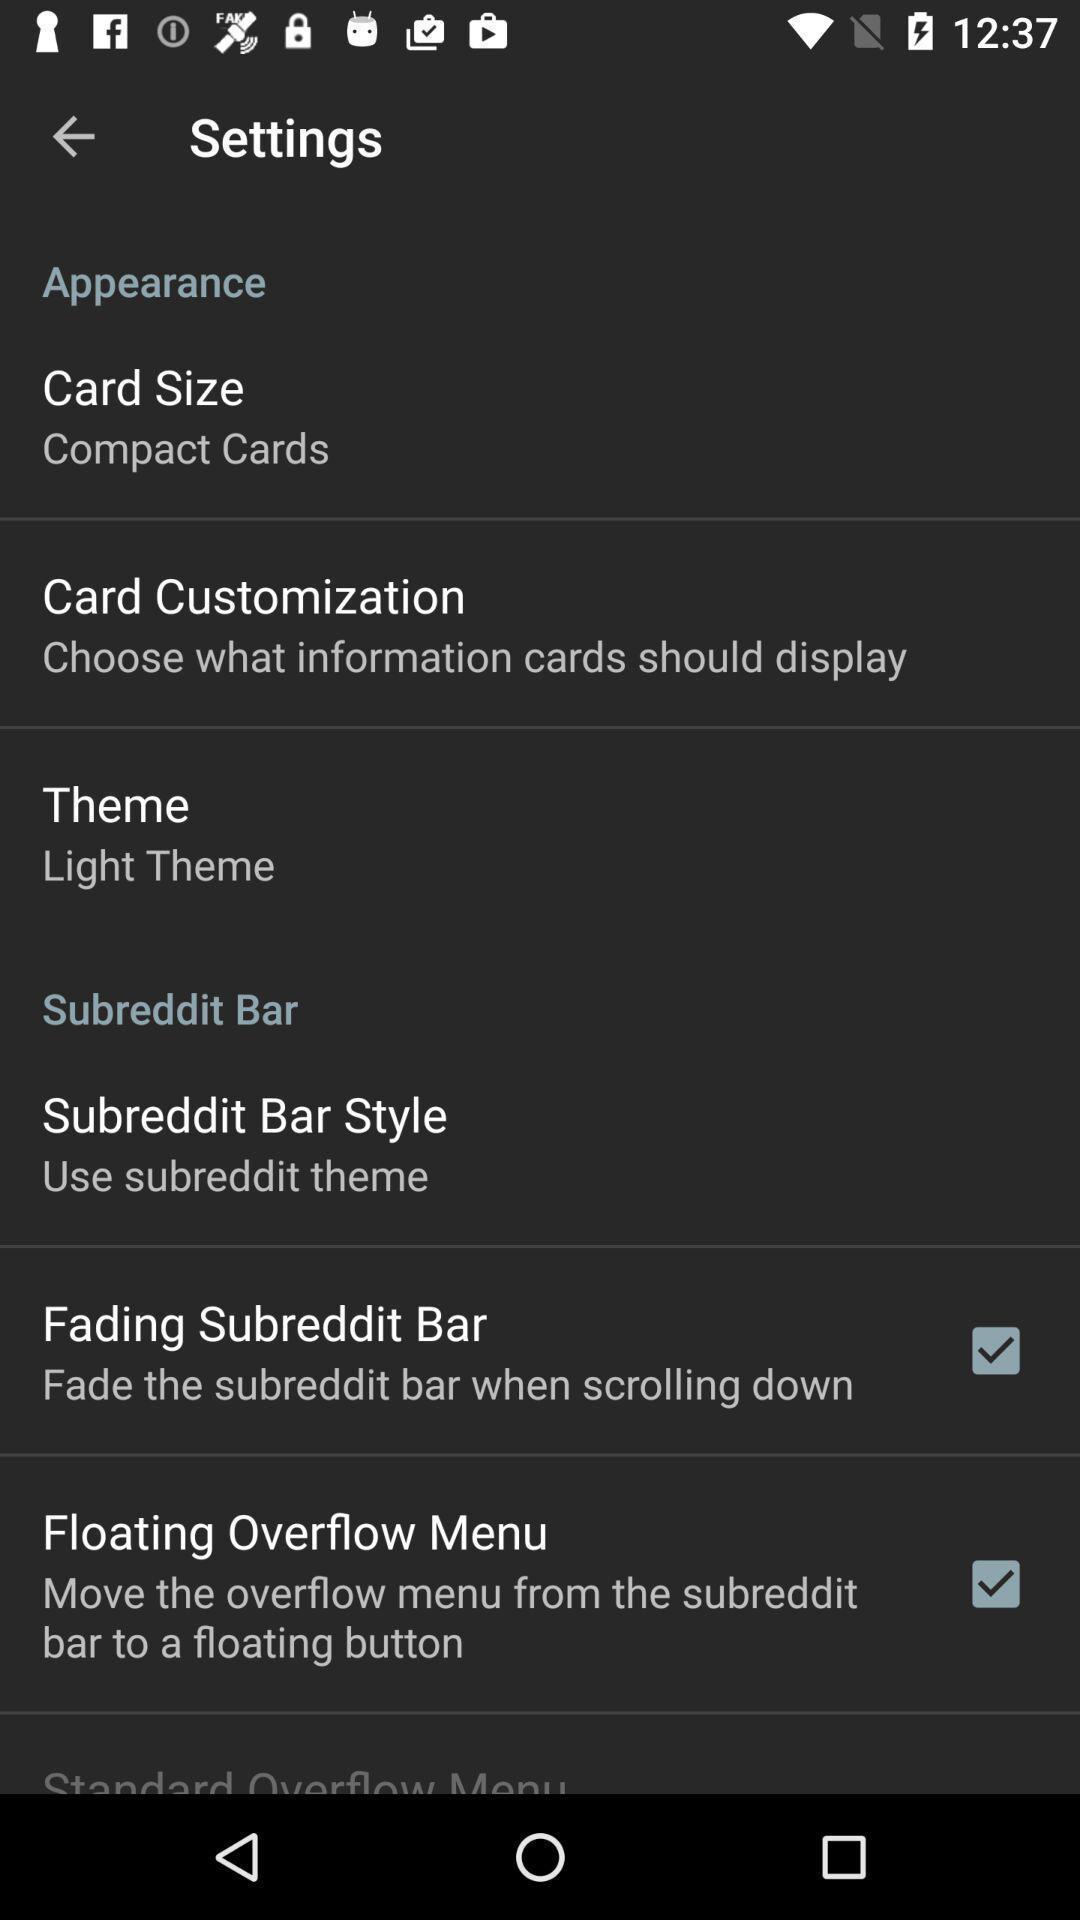Tell me about the visual elements in this screen capture. Settings page displayed. 